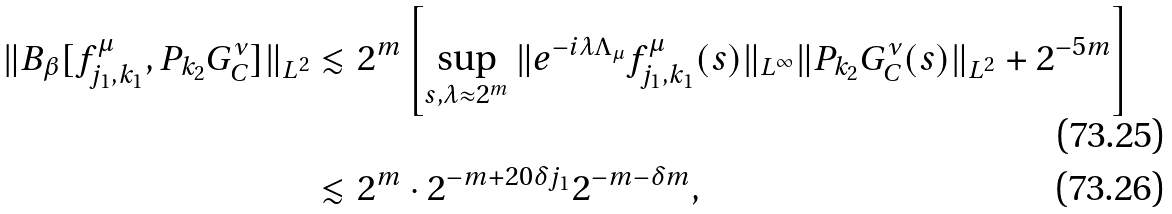<formula> <loc_0><loc_0><loc_500><loc_500>\| B _ { \beta } [ f ^ { \mu } _ { j _ { 1 } , k _ { 1 } } , P _ { k _ { 2 } } G ^ { \nu } _ { C } ] \| _ { L ^ { 2 } } & \lesssim 2 ^ { m } \left [ \sup _ { s , \lambda \approx 2 ^ { m } } \| e ^ { - i \lambda \Lambda _ { \mu } } f ^ { \mu } _ { j _ { 1 } , k _ { 1 } } ( s ) \| _ { L ^ { \infty } } \| P _ { k _ { 2 } } G ^ { \nu } _ { C } ( s ) \| _ { L ^ { 2 } } + 2 ^ { - 5 m } \right ] \\ & \lesssim 2 ^ { m } \cdot 2 ^ { - m + 2 0 \delta j _ { 1 } } 2 ^ { - m - \delta m } ,</formula> 